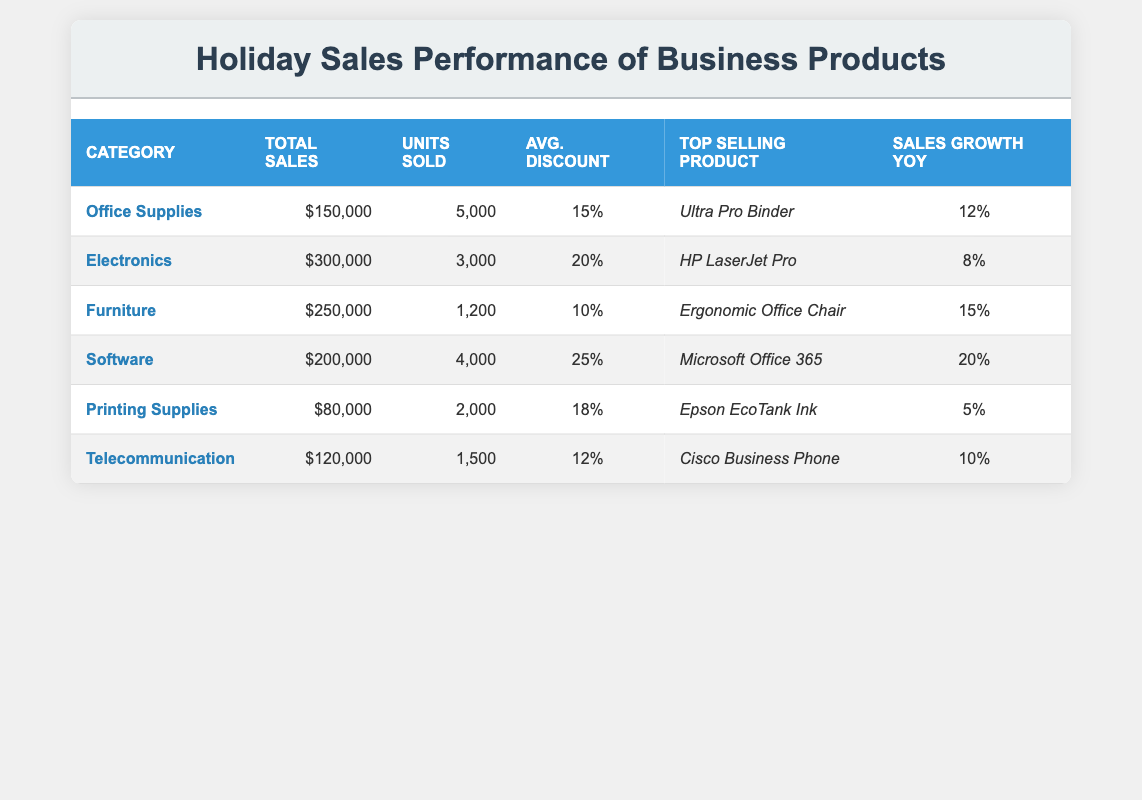What is the total sales amount for Office Supplies? The table lists the total sales for each category, and for Office Supplies, it shows a total sales figure of $150,000.
Answer: $150,000 Which category had the highest sales growth year-over-year? The table shows the sales growth year-over-year for all categories. Software has the highest sales growth at 20%.
Answer: Software How many units were sold in the Furniture category? By looking up the Furniture category in the table, we can see that 1,200 units were sold.
Answer: 1,200 What is the average discount across all categories? To calculate the average discount, add all the average discounts together (15 + 20 + 10 + 25 + 18 + 12 = 110) and then divide by the number of categories (110/6 = 18.33).
Answer: 18.33% Which product had the highest average discount? The table lists the average discount for each category, and Software offers the highest average discount at 25%.
Answer: Microsoft Office 365 Is the total sales for Printing Supplies greater than that of Telecommunication? The total sales for Printing Supplies is $80,000 and for Telecommunication is $120,000. Since $80,000 is not greater than $120,000, the answer is no.
Answer: No What is the difference in total sales between Electronics and Office Supplies? The total sales for Electronics is $300,000 and for Office Supplies is $150,000. The difference is calculated as $300,000 - $150,000 = $150,000.
Answer: $150,000 Which category sold the most units? By checking the units sold in each category, Office Supplies sold 5,000 units, which is more than any other category, making it the highest.
Answer: Office Supplies Calculate the total sales for categories that had an average discount greater than 15%. The categories with an average discount greater than 15% are Software (200,000) and Electronics (300,000). The total sales for these categories add up to $200,000 + $300,000 = $500,000.
Answer: $500,000 Which top-selling product corresponds to the category with the lowest number of units sold? From the table, Printing Supplies has the lowest units sold at 2,000. The top-selling product in that category is Epson EcoTank Ink.
Answer: Epson EcoTank Ink 